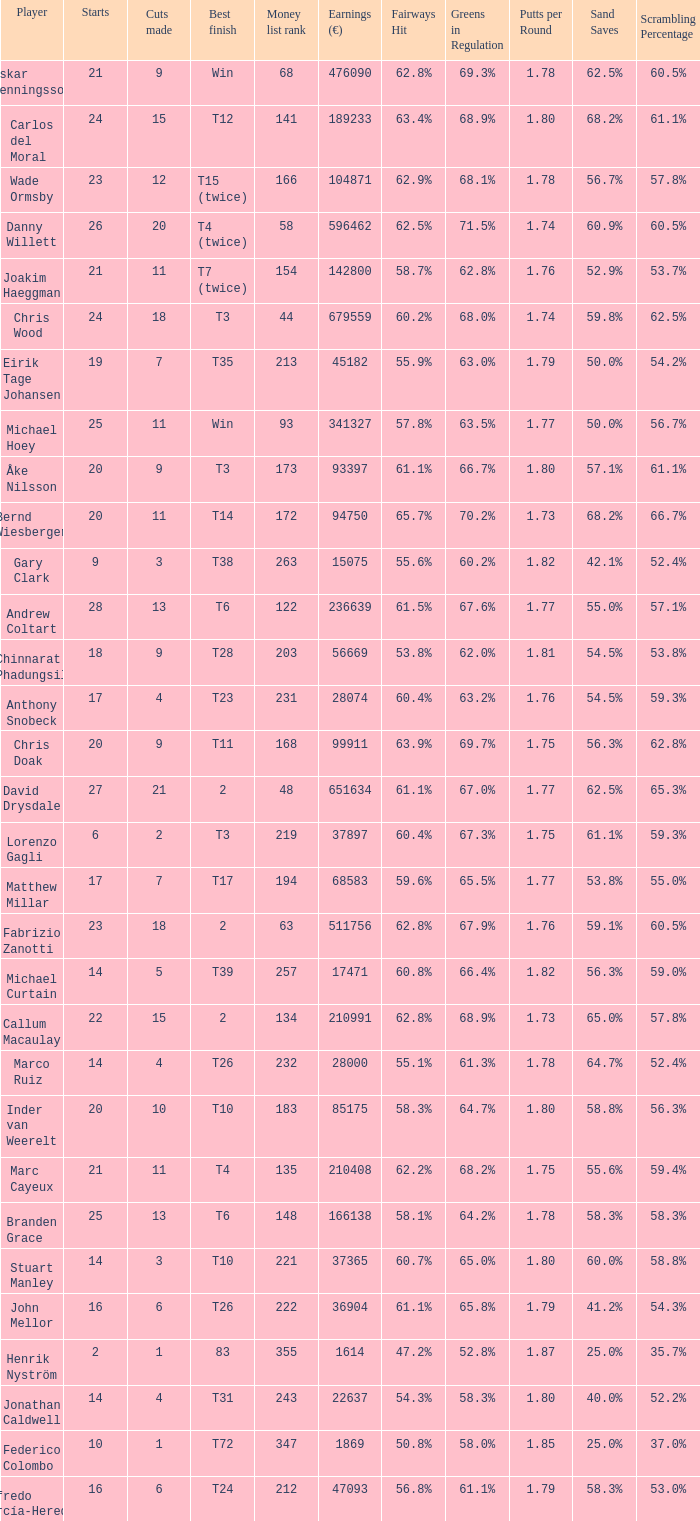Which player made exactly 26 starts? Danny Willett. 